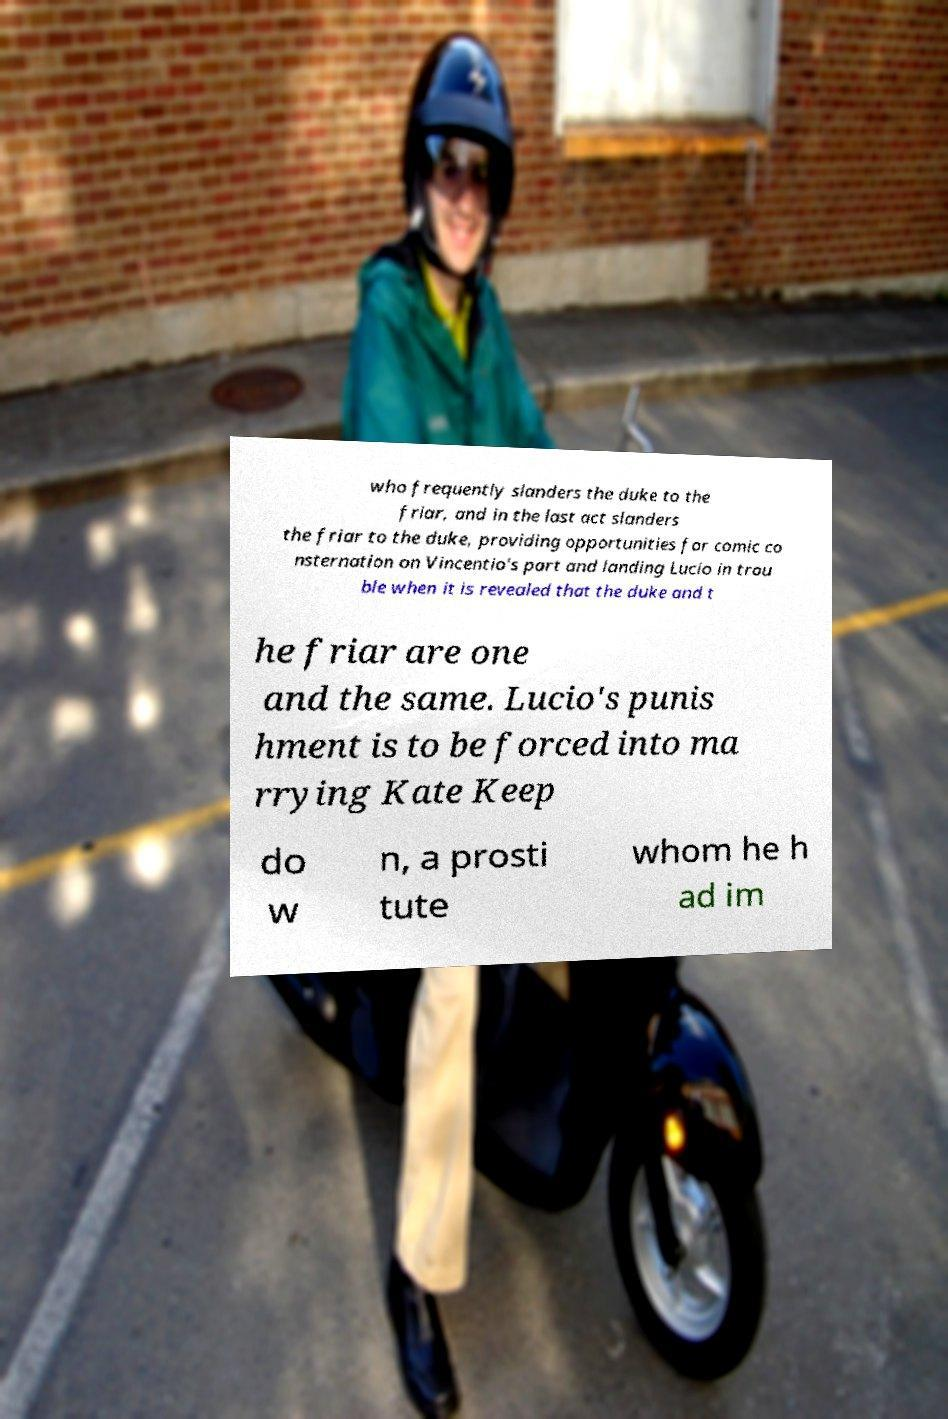Please read and relay the text visible in this image. What does it say? who frequently slanders the duke to the friar, and in the last act slanders the friar to the duke, providing opportunities for comic co nsternation on Vincentio's part and landing Lucio in trou ble when it is revealed that the duke and t he friar are one and the same. Lucio's punis hment is to be forced into ma rrying Kate Keep do w n, a prosti tute whom he h ad im 